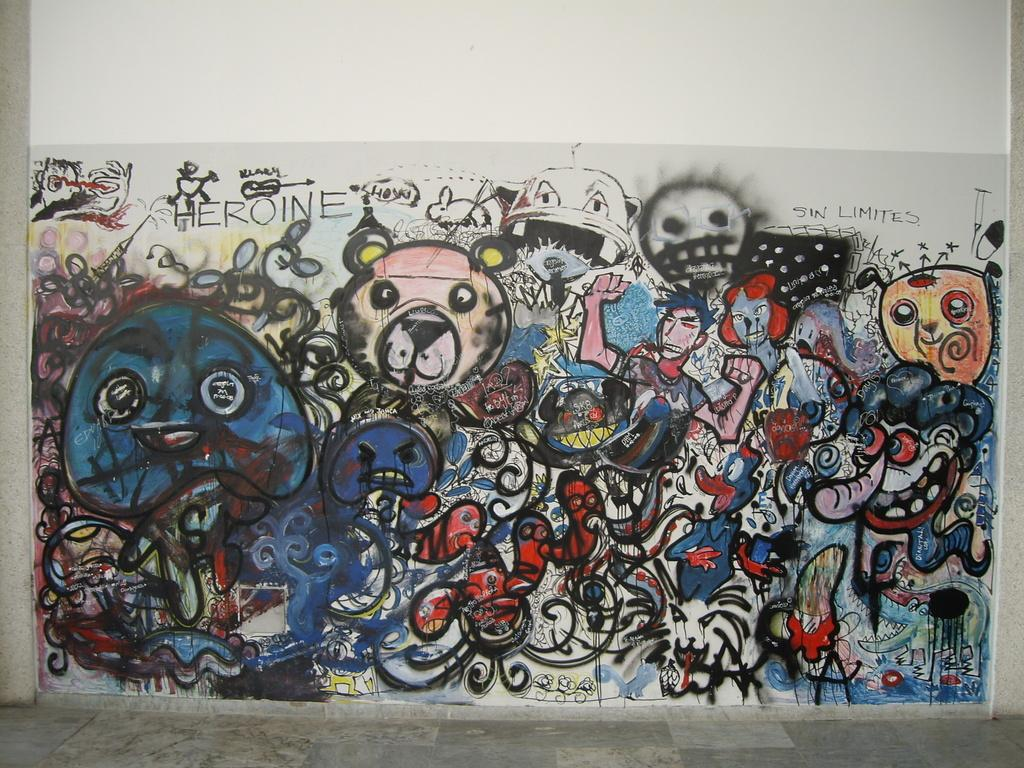What can be seen on the wall in the image? There is a painting on the wall in the image. What is featured on the painting? There is text written on the painting. How is the distribution of the stem affecting the match in the image? There is no stem or match present in the image; it only features a painting with text. 